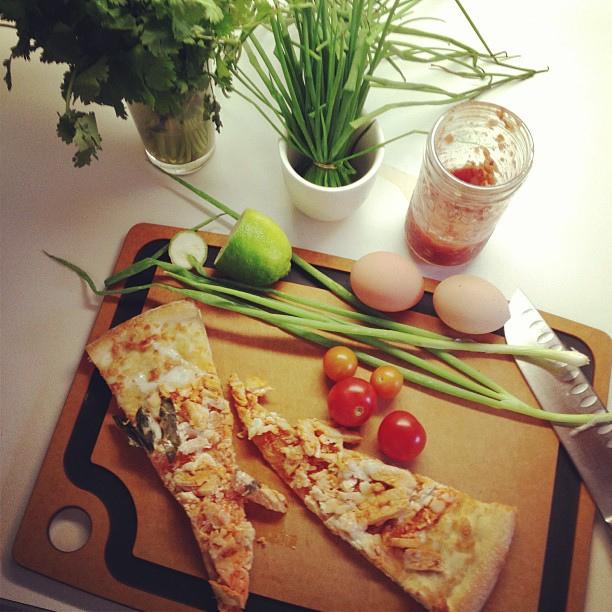Which greens are bundled?
Short answer required. Onions. What kind of vegetables are these?
Write a very short answer. Tomatoes. How many pieces of pizza are there?
Short answer required. 2. Is this airline food?
Short answer required. No. 